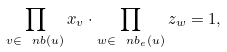Convert formula to latex. <formula><loc_0><loc_0><loc_500><loc_500>\prod _ { v \in \ n b ( u ) } x _ { v } \cdot \prod _ { w \in \ n b _ { e } ( u ) } z _ { w } = 1 ,</formula> 